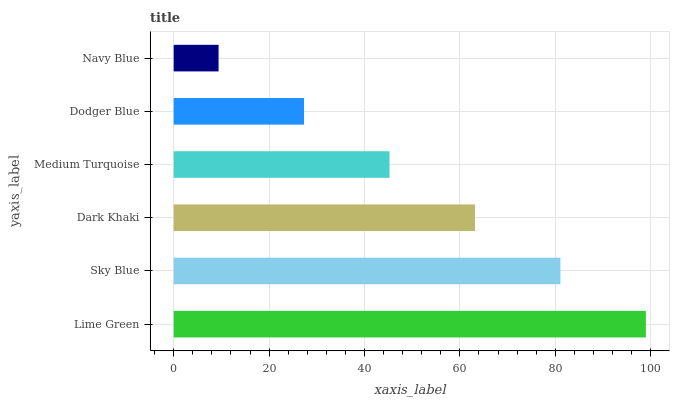Is Navy Blue the minimum?
Answer yes or no. Yes. Is Lime Green the maximum?
Answer yes or no. Yes. Is Sky Blue the minimum?
Answer yes or no. No. Is Sky Blue the maximum?
Answer yes or no. No. Is Lime Green greater than Sky Blue?
Answer yes or no. Yes. Is Sky Blue less than Lime Green?
Answer yes or no. Yes. Is Sky Blue greater than Lime Green?
Answer yes or no. No. Is Lime Green less than Sky Blue?
Answer yes or no. No. Is Dark Khaki the high median?
Answer yes or no. Yes. Is Medium Turquoise the low median?
Answer yes or no. Yes. Is Dodger Blue the high median?
Answer yes or no. No. Is Lime Green the low median?
Answer yes or no. No. 